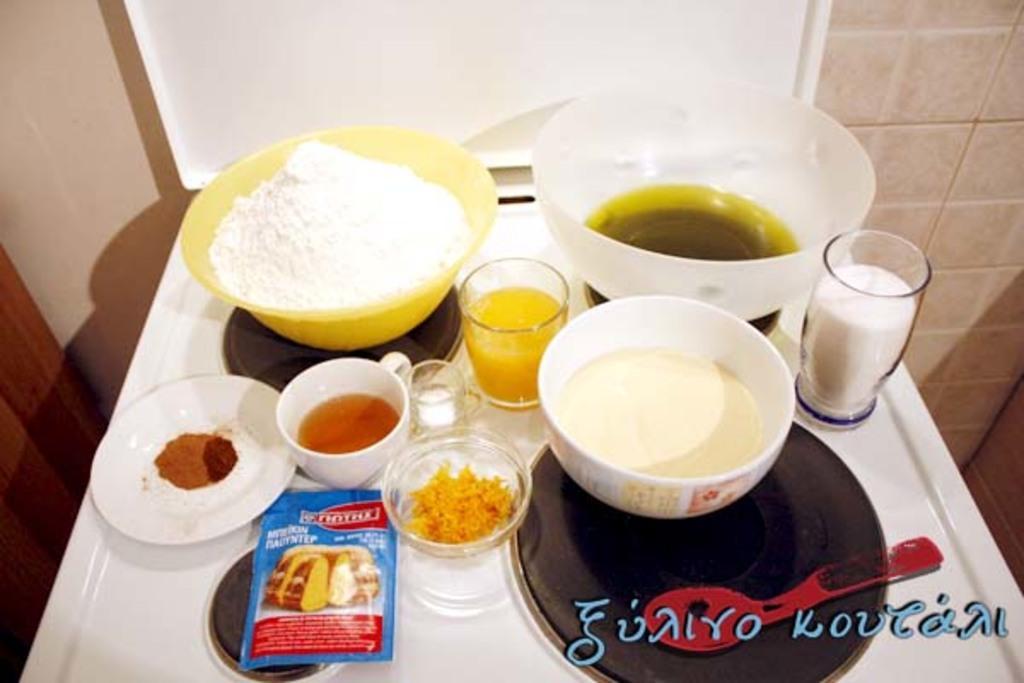Describe this image in one or two sentences. In this image there are some food items in bowls and some drinks in glasses and there is a spoon and a sachet on a table, at the bottom of the image there is some text, behind the table there is a board on the tile wall. 